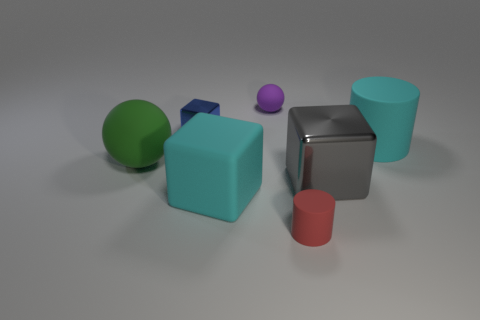How many things are either red rubber spheres or big green objects?
Provide a short and direct response. 1. What is the material of the cylinder that is behind the matte ball that is in front of the small purple thing?
Your answer should be compact. Rubber. Are there any big gray objects that have the same material as the large cyan cylinder?
Provide a short and direct response. No. There is a object that is behind the blue cube left of the cube that is to the right of the cyan matte block; what is its shape?
Make the answer very short. Sphere. What is the small blue cube made of?
Give a very brief answer. Metal. The other sphere that is the same material as the small purple sphere is what color?
Your answer should be very brief. Green. Are there any spheres that are in front of the rubber cylinder to the right of the red cylinder?
Provide a short and direct response. Yes. How many other objects are there of the same shape as the red matte thing?
Make the answer very short. 1. There is a cyan matte object that is left of the tiny matte cylinder; does it have the same shape as the cyan matte thing that is behind the green thing?
Offer a terse response. No. How many matte cubes are to the right of the cyan matte thing behind the cyan rubber thing that is left of the large gray metal block?
Offer a very short reply. 0. 